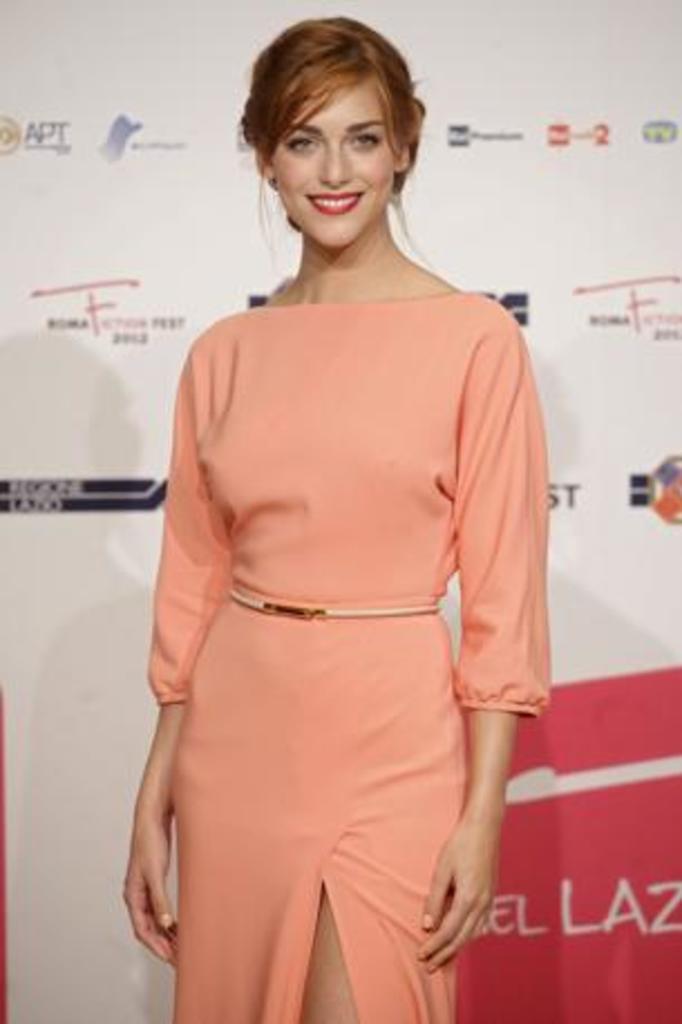Can you describe this image briefly? In this image in the center there is one woman standing and smiling, and in the background there is a board. On the board there are some logos and text. 